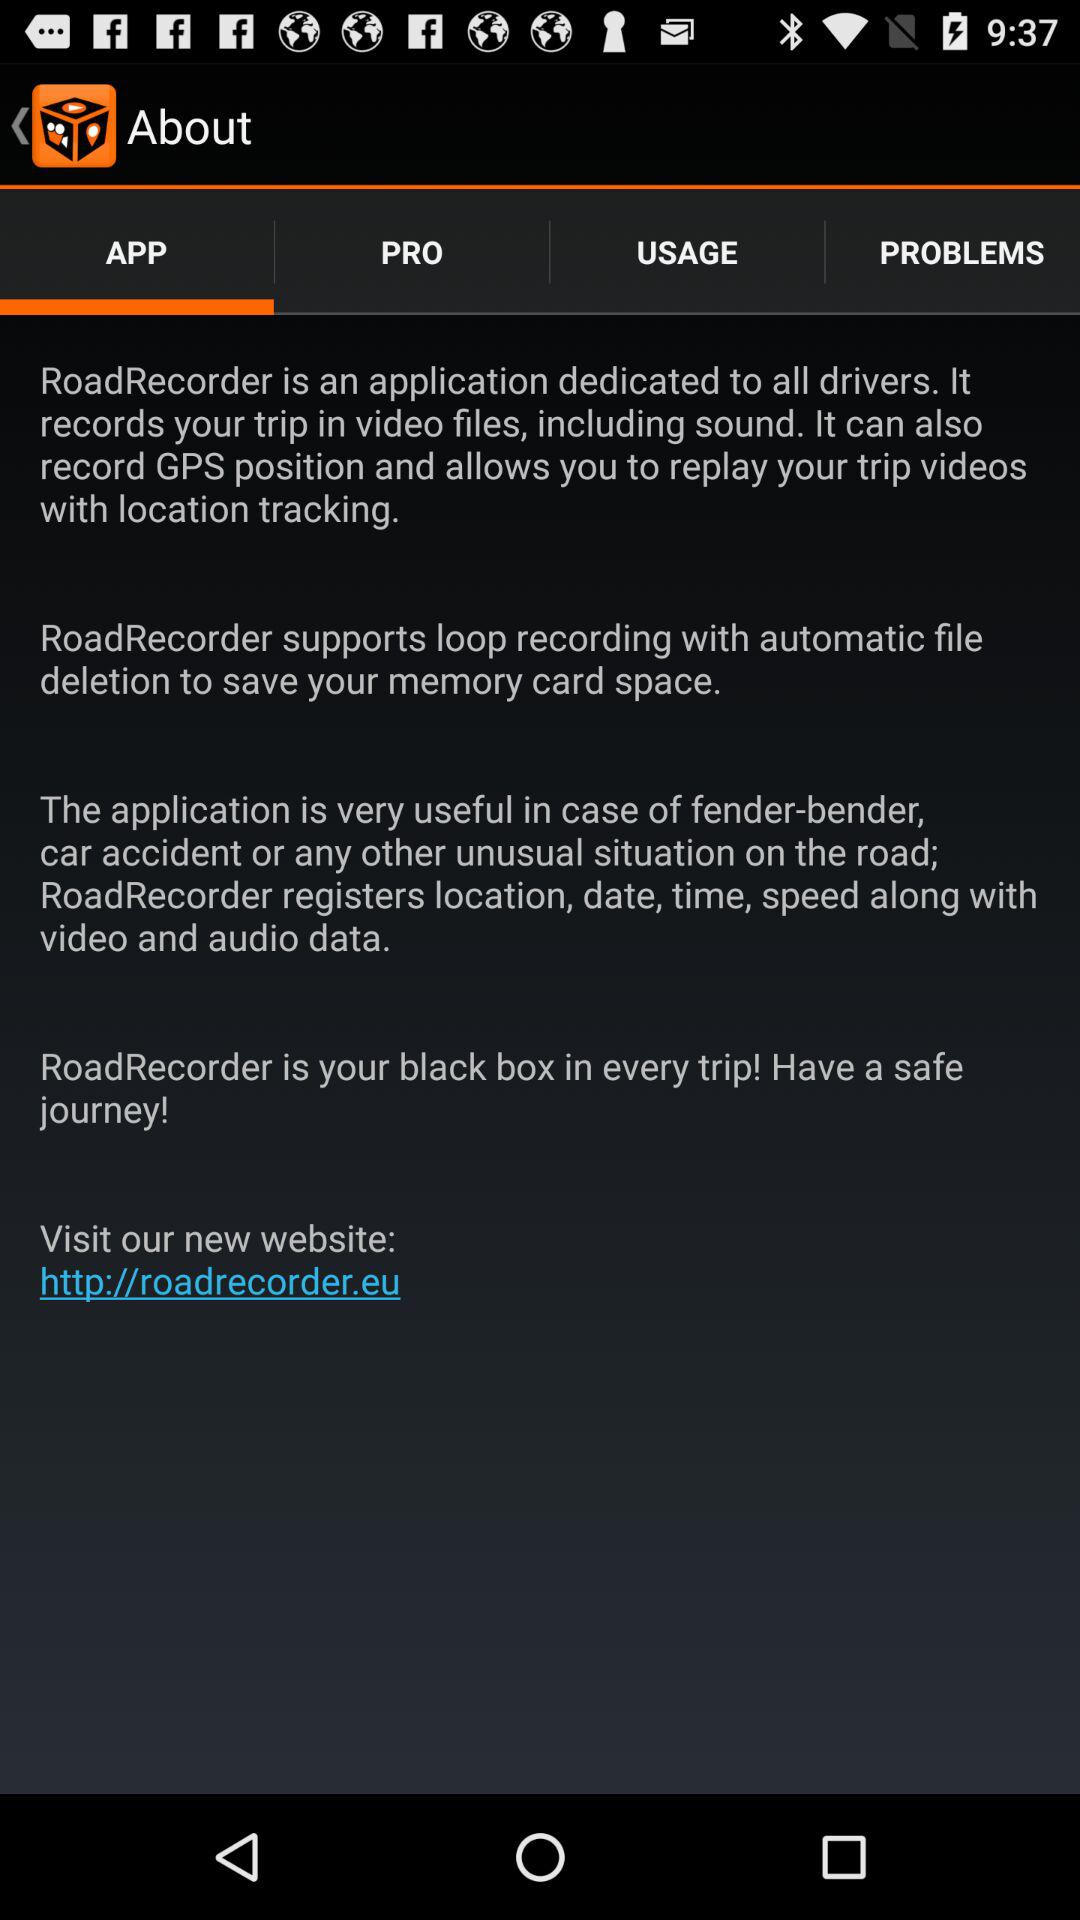Which tab am I on? You are on "APP" tab. 